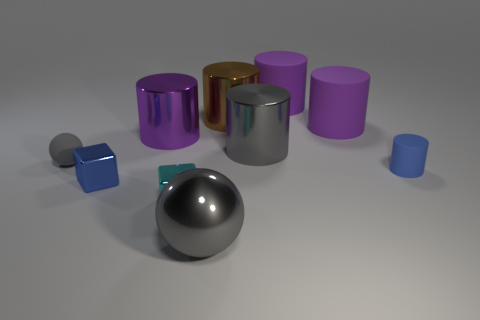Are there any big cylinders to the left of the metal ball?
Give a very brief answer. Yes. There is a gray metal object in front of the blue metallic object; what number of matte objects are to the right of it?
Offer a terse response. 3. The blue thing that is made of the same material as the big brown cylinder is what size?
Offer a terse response. Small. How big is the blue metal thing?
Give a very brief answer. Small. Does the small cyan object have the same material as the big brown cylinder?
Give a very brief answer. Yes. How many blocks are either tiny cyan matte objects or small cyan things?
Offer a very short reply. 1. There is a small matte object right of the large gray object that is in front of the gray shiny cylinder; what color is it?
Your response must be concise. Blue. There is a shiny sphere that is the same color as the small rubber ball; what size is it?
Your answer should be compact. Large. How many big cylinders are to the right of the large shiny object in front of the gray metal thing that is behind the blue metal block?
Offer a very short reply. 4. Is the shape of the blue thing that is on the left side of the large gray ball the same as the tiny cyan object behind the big gray metal ball?
Give a very brief answer. Yes. 